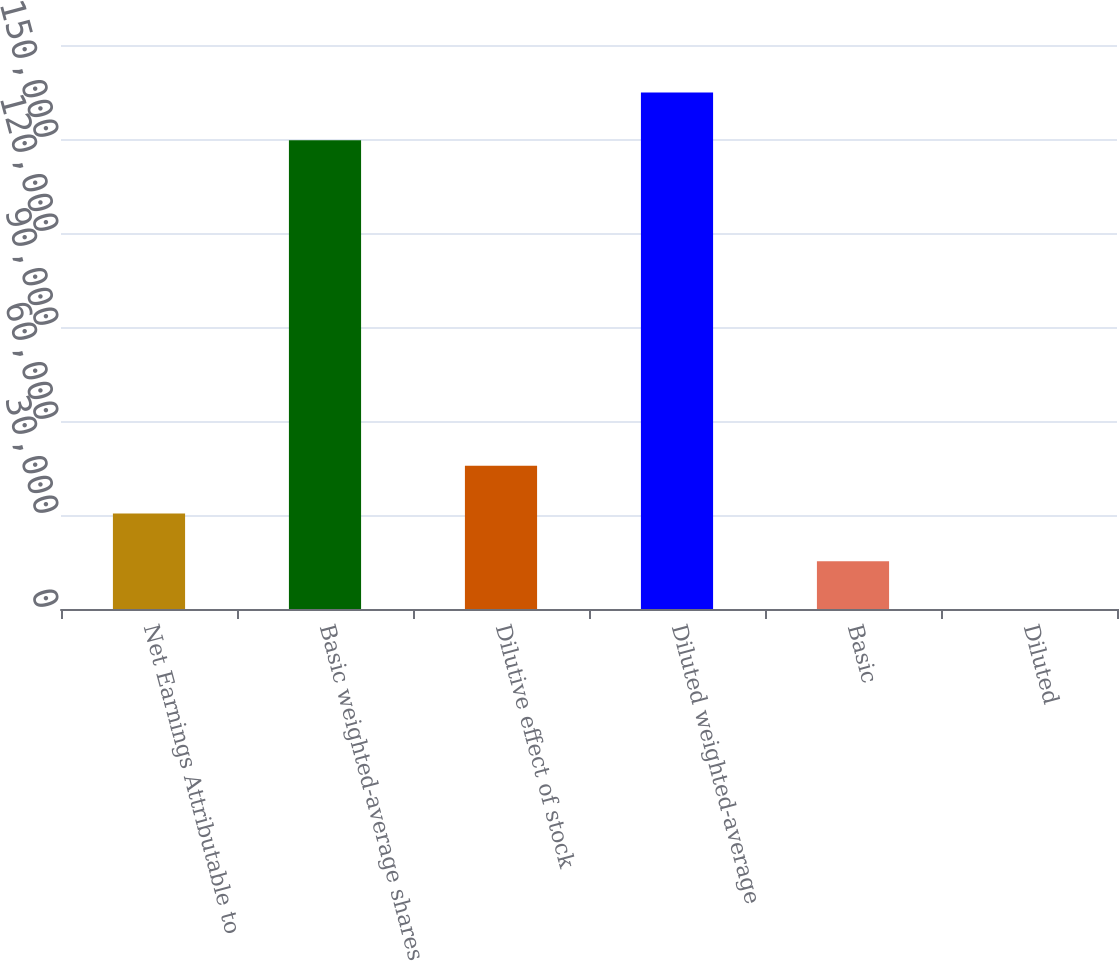Convert chart to OTSL. <chart><loc_0><loc_0><loc_500><loc_500><bar_chart><fcel>Net Earnings Attributable to<fcel>Basic weighted-average shares<fcel>Dilutive effect of stock<fcel>Diluted weighted-average<fcel>Basic<fcel>Diluted<nl><fcel>30496.2<fcel>149629<fcel>45740.3<fcel>164873<fcel>15252.1<fcel>8.05<nl></chart> 